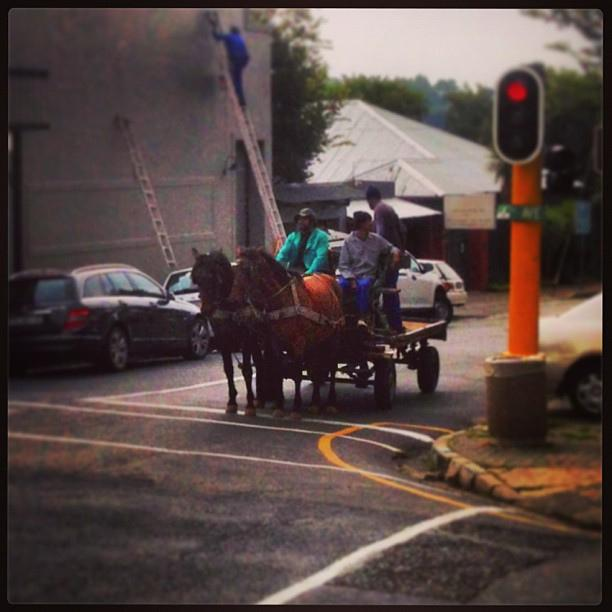What color is the big horse to the right with the flat cart behind it? Please explain your reasoning. chestnut. The horses are brown which is typical of this animal.  this color is a shade of brown. 